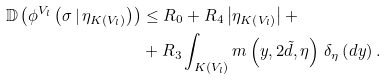<formula> <loc_0><loc_0><loc_500><loc_500>\mathbb { D } \left ( \phi ^ { V _ { l } } \left ( \sigma \, | \, \eta _ { K \left ( V _ { l } \right ) } \right ) \right ) & \leq R _ { 0 } + R _ { 4 } \left | \eta _ { K \left ( V _ { l } \right ) } \right | + \\ & + R _ { 3 } \int _ { K \left ( V _ { l } \right ) } m \left ( y , 2 \tilde { d } , \eta \right ) \, \delta _ { \eta } \left ( d y \right ) .</formula> 